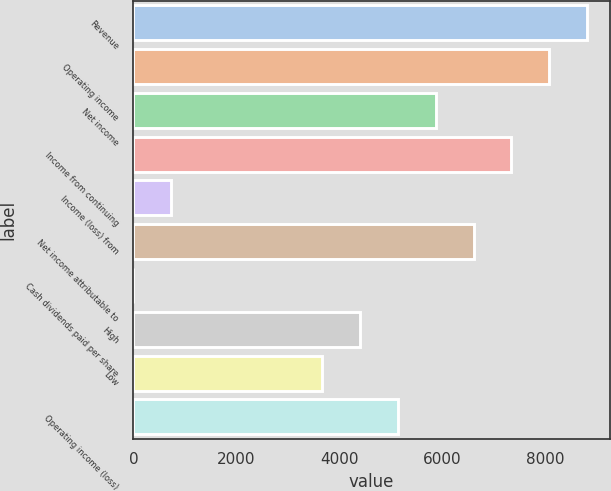Convert chart. <chart><loc_0><loc_0><loc_500><loc_500><bar_chart><fcel>Revenue<fcel>Operating income<fcel>Net income<fcel>Income from continuing<fcel>Income (loss) from<fcel>Net income attributable to<fcel>Cash dividends paid per share<fcel>High<fcel>Low<fcel>Operating income (loss)<nl><fcel>8817.62<fcel>8082.84<fcel>5878.47<fcel>7348.05<fcel>734.94<fcel>6613.26<fcel>0.15<fcel>4408.89<fcel>3674.1<fcel>5143.68<nl></chart> 